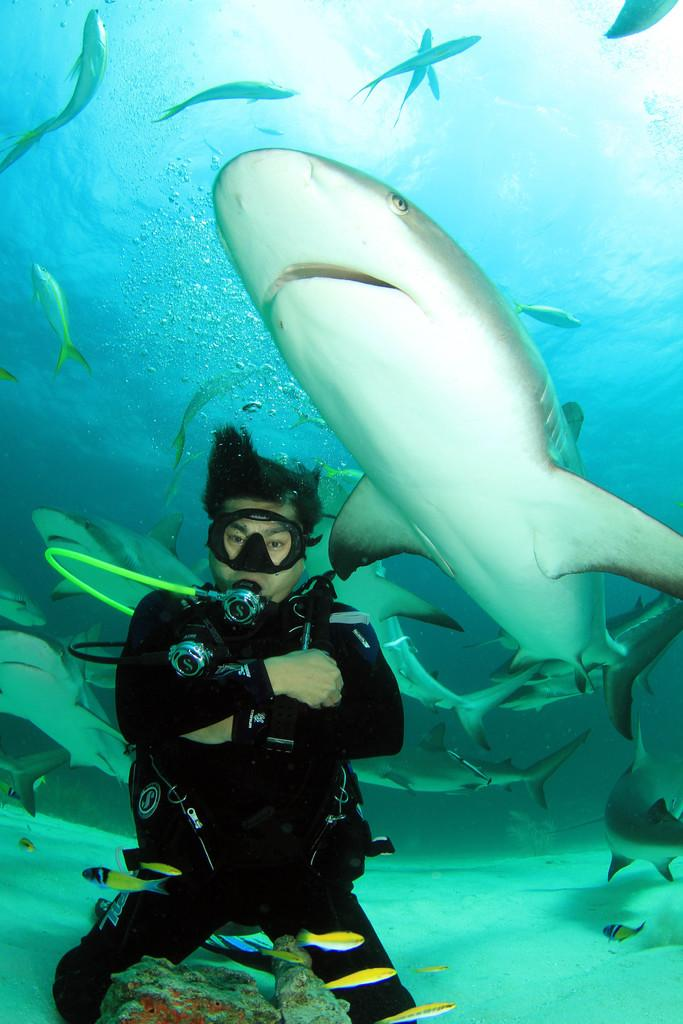What is the setting of the image? The image is taken underwater. Can you describe the person in the image? There is a person wearing a swimsuit in the image. What other living organisms can be seen in the image? There are fishes in the image. What type of food is being smashed by the crowd in the image? There is no food or crowd present in the image; it is taken underwater and features a person and fishes. 